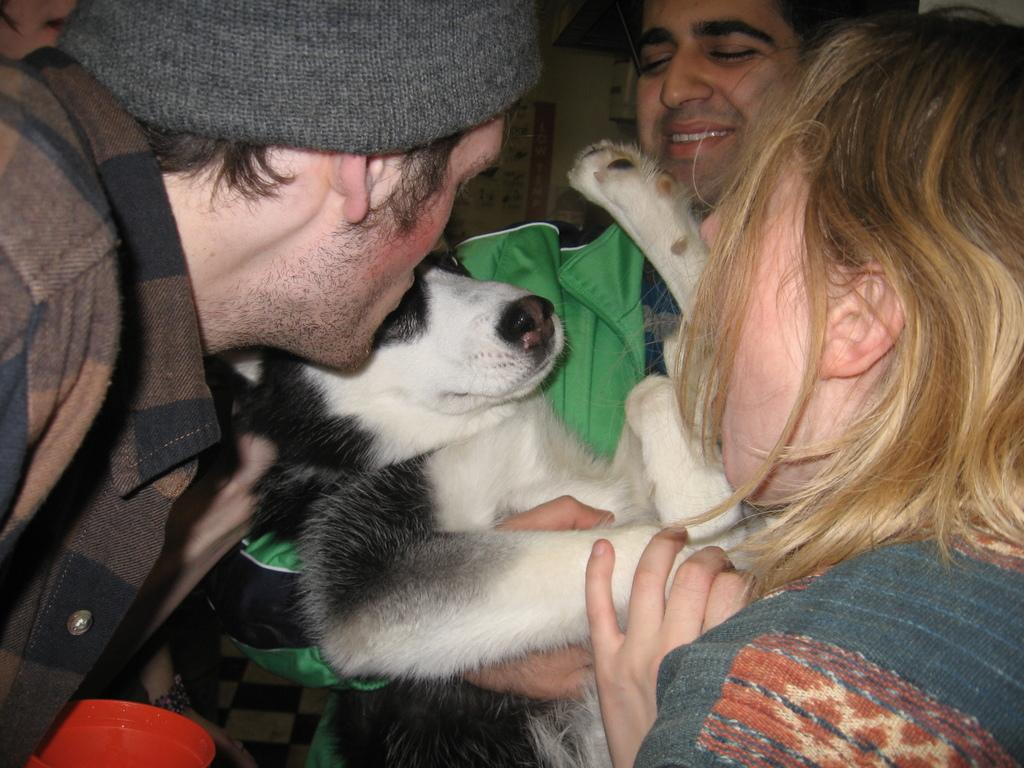How many people are in the image? There are three people in the image. What are the people doing in the image? The people are playing with a dog. Can you describe the dog in the image? The dog is white and is wearing a green coat. What type of jam is the dog eating in the image? There is no jam present in the image; the dog is playing with the people. 